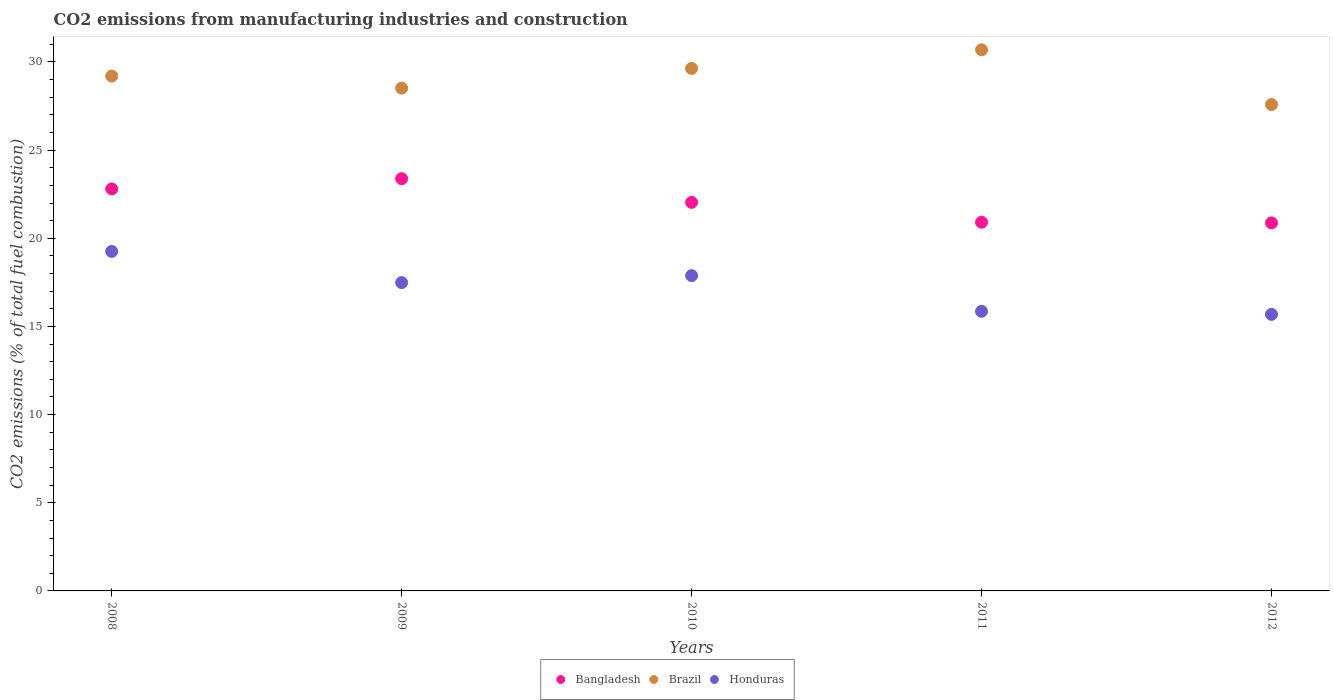Is the number of dotlines equal to the number of legend labels?
Your answer should be very brief. Yes. What is the amount of CO2 emitted in Bangladesh in 2008?
Your answer should be very brief. 22.8. Across all years, what is the maximum amount of CO2 emitted in Brazil?
Provide a succinct answer. 30.69. Across all years, what is the minimum amount of CO2 emitted in Bangladesh?
Offer a terse response. 20.87. In which year was the amount of CO2 emitted in Bangladesh minimum?
Ensure brevity in your answer.  2012. What is the total amount of CO2 emitted in Brazil in the graph?
Offer a terse response. 145.63. What is the difference between the amount of CO2 emitted in Honduras in 2008 and that in 2010?
Provide a short and direct response. 1.37. What is the difference between the amount of CO2 emitted in Brazil in 2010 and the amount of CO2 emitted in Honduras in 2009?
Keep it short and to the point. 12.15. What is the average amount of CO2 emitted in Bangladesh per year?
Keep it short and to the point. 22. In the year 2009, what is the difference between the amount of CO2 emitted in Bangladesh and amount of CO2 emitted in Brazil?
Make the answer very short. -5.14. What is the ratio of the amount of CO2 emitted in Bangladesh in 2011 to that in 2012?
Give a very brief answer. 1. Is the difference between the amount of CO2 emitted in Bangladesh in 2010 and 2012 greater than the difference between the amount of CO2 emitted in Brazil in 2010 and 2012?
Make the answer very short. No. What is the difference between the highest and the second highest amount of CO2 emitted in Brazil?
Ensure brevity in your answer.  1.06. What is the difference between the highest and the lowest amount of CO2 emitted in Bangladesh?
Your answer should be compact. 2.51. In how many years, is the amount of CO2 emitted in Brazil greater than the average amount of CO2 emitted in Brazil taken over all years?
Keep it short and to the point. 3. Is the sum of the amount of CO2 emitted in Bangladesh in 2008 and 2012 greater than the maximum amount of CO2 emitted in Honduras across all years?
Ensure brevity in your answer.  Yes. Is it the case that in every year, the sum of the amount of CO2 emitted in Honduras and amount of CO2 emitted in Brazil  is greater than the amount of CO2 emitted in Bangladesh?
Ensure brevity in your answer.  Yes. Is the amount of CO2 emitted in Bangladesh strictly less than the amount of CO2 emitted in Brazil over the years?
Give a very brief answer. Yes. Does the graph contain any zero values?
Your answer should be very brief. No. Does the graph contain grids?
Your answer should be compact. No. What is the title of the graph?
Ensure brevity in your answer.  CO2 emissions from manufacturing industries and construction. Does "Papua New Guinea" appear as one of the legend labels in the graph?
Ensure brevity in your answer.  No. What is the label or title of the X-axis?
Your answer should be very brief. Years. What is the label or title of the Y-axis?
Give a very brief answer. CO2 emissions (% of total fuel combustion). What is the CO2 emissions (% of total fuel combustion) in Bangladesh in 2008?
Offer a very short reply. 22.8. What is the CO2 emissions (% of total fuel combustion) in Brazil in 2008?
Offer a very short reply. 29.2. What is the CO2 emissions (% of total fuel combustion) of Honduras in 2008?
Make the answer very short. 19.26. What is the CO2 emissions (% of total fuel combustion) in Bangladesh in 2009?
Your answer should be compact. 23.38. What is the CO2 emissions (% of total fuel combustion) of Brazil in 2009?
Provide a succinct answer. 28.52. What is the CO2 emissions (% of total fuel combustion) of Honduras in 2009?
Your answer should be very brief. 17.49. What is the CO2 emissions (% of total fuel combustion) of Bangladesh in 2010?
Offer a terse response. 22.04. What is the CO2 emissions (% of total fuel combustion) in Brazil in 2010?
Provide a short and direct response. 29.63. What is the CO2 emissions (% of total fuel combustion) of Honduras in 2010?
Ensure brevity in your answer.  17.88. What is the CO2 emissions (% of total fuel combustion) in Bangladesh in 2011?
Your answer should be compact. 20.91. What is the CO2 emissions (% of total fuel combustion) of Brazil in 2011?
Give a very brief answer. 30.69. What is the CO2 emissions (% of total fuel combustion) of Honduras in 2011?
Offer a very short reply. 15.86. What is the CO2 emissions (% of total fuel combustion) in Bangladesh in 2012?
Your answer should be compact. 20.87. What is the CO2 emissions (% of total fuel combustion) in Brazil in 2012?
Keep it short and to the point. 27.58. What is the CO2 emissions (% of total fuel combustion) of Honduras in 2012?
Make the answer very short. 15.69. Across all years, what is the maximum CO2 emissions (% of total fuel combustion) of Bangladesh?
Your answer should be compact. 23.38. Across all years, what is the maximum CO2 emissions (% of total fuel combustion) in Brazil?
Make the answer very short. 30.69. Across all years, what is the maximum CO2 emissions (% of total fuel combustion) of Honduras?
Keep it short and to the point. 19.26. Across all years, what is the minimum CO2 emissions (% of total fuel combustion) in Bangladesh?
Offer a terse response. 20.87. Across all years, what is the minimum CO2 emissions (% of total fuel combustion) in Brazil?
Offer a very short reply. 27.58. Across all years, what is the minimum CO2 emissions (% of total fuel combustion) of Honduras?
Offer a terse response. 15.69. What is the total CO2 emissions (% of total fuel combustion) of Bangladesh in the graph?
Keep it short and to the point. 110.01. What is the total CO2 emissions (% of total fuel combustion) in Brazil in the graph?
Give a very brief answer. 145.63. What is the total CO2 emissions (% of total fuel combustion) in Honduras in the graph?
Your response must be concise. 86.17. What is the difference between the CO2 emissions (% of total fuel combustion) in Bangladesh in 2008 and that in 2009?
Your answer should be very brief. -0.58. What is the difference between the CO2 emissions (% of total fuel combustion) in Brazil in 2008 and that in 2009?
Offer a terse response. 0.68. What is the difference between the CO2 emissions (% of total fuel combustion) of Honduras in 2008 and that in 2009?
Your answer should be very brief. 1.77. What is the difference between the CO2 emissions (% of total fuel combustion) in Bangladesh in 2008 and that in 2010?
Your answer should be very brief. 0.76. What is the difference between the CO2 emissions (% of total fuel combustion) in Brazil in 2008 and that in 2010?
Offer a very short reply. -0.43. What is the difference between the CO2 emissions (% of total fuel combustion) in Honduras in 2008 and that in 2010?
Keep it short and to the point. 1.37. What is the difference between the CO2 emissions (% of total fuel combustion) in Bangladesh in 2008 and that in 2011?
Offer a terse response. 1.89. What is the difference between the CO2 emissions (% of total fuel combustion) of Brazil in 2008 and that in 2011?
Give a very brief answer. -1.49. What is the difference between the CO2 emissions (% of total fuel combustion) of Honduras in 2008 and that in 2011?
Keep it short and to the point. 3.4. What is the difference between the CO2 emissions (% of total fuel combustion) of Bangladesh in 2008 and that in 2012?
Your answer should be very brief. 1.93. What is the difference between the CO2 emissions (% of total fuel combustion) of Brazil in 2008 and that in 2012?
Offer a terse response. 1.62. What is the difference between the CO2 emissions (% of total fuel combustion) of Honduras in 2008 and that in 2012?
Give a very brief answer. 3.57. What is the difference between the CO2 emissions (% of total fuel combustion) of Bangladesh in 2009 and that in 2010?
Offer a very short reply. 1.34. What is the difference between the CO2 emissions (% of total fuel combustion) in Brazil in 2009 and that in 2010?
Keep it short and to the point. -1.11. What is the difference between the CO2 emissions (% of total fuel combustion) in Honduras in 2009 and that in 2010?
Make the answer very short. -0.4. What is the difference between the CO2 emissions (% of total fuel combustion) of Bangladesh in 2009 and that in 2011?
Offer a terse response. 2.47. What is the difference between the CO2 emissions (% of total fuel combustion) of Brazil in 2009 and that in 2011?
Make the answer very short. -2.17. What is the difference between the CO2 emissions (% of total fuel combustion) in Honduras in 2009 and that in 2011?
Provide a succinct answer. 1.63. What is the difference between the CO2 emissions (% of total fuel combustion) in Bangladesh in 2009 and that in 2012?
Provide a short and direct response. 2.51. What is the difference between the CO2 emissions (% of total fuel combustion) of Honduras in 2009 and that in 2012?
Keep it short and to the point. 1.8. What is the difference between the CO2 emissions (% of total fuel combustion) of Bangladesh in 2010 and that in 2011?
Make the answer very short. 1.13. What is the difference between the CO2 emissions (% of total fuel combustion) of Brazil in 2010 and that in 2011?
Make the answer very short. -1.06. What is the difference between the CO2 emissions (% of total fuel combustion) in Honduras in 2010 and that in 2011?
Make the answer very short. 2.02. What is the difference between the CO2 emissions (% of total fuel combustion) in Bangladesh in 2010 and that in 2012?
Make the answer very short. 1.16. What is the difference between the CO2 emissions (% of total fuel combustion) in Brazil in 2010 and that in 2012?
Ensure brevity in your answer.  2.05. What is the difference between the CO2 emissions (% of total fuel combustion) in Honduras in 2010 and that in 2012?
Provide a succinct answer. 2.2. What is the difference between the CO2 emissions (% of total fuel combustion) in Bangladesh in 2011 and that in 2012?
Your answer should be compact. 0.04. What is the difference between the CO2 emissions (% of total fuel combustion) in Brazil in 2011 and that in 2012?
Offer a very short reply. 3.11. What is the difference between the CO2 emissions (% of total fuel combustion) of Honduras in 2011 and that in 2012?
Make the answer very short. 0.17. What is the difference between the CO2 emissions (% of total fuel combustion) of Bangladesh in 2008 and the CO2 emissions (% of total fuel combustion) of Brazil in 2009?
Make the answer very short. -5.72. What is the difference between the CO2 emissions (% of total fuel combustion) in Bangladesh in 2008 and the CO2 emissions (% of total fuel combustion) in Honduras in 2009?
Your response must be concise. 5.32. What is the difference between the CO2 emissions (% of total fuel combustion) of Brazil in 2008 and the CO2 emissions (% of total fuel combustion) of Honduras in 2009?
Keep it short and to the point. 11.72. What is the difference between the CO2 emissions (% of total fuel combustion) in Bangladesh in 2008 and the CO2 emissions (% of total fuel combustion) in Brazil in 2010?
Offer a very short reply. -6.83. What is the difference between the CO2 emissions (% of total fuel combustion) in Bangladesh in 2008 and the CO2 emissions (% of total fuel combustion) in Honduras in 2010?
Give a very brief answer. 4.92. What is the difference between the CO2 emissions (% of total fuel combustion) in Brazil in 2008 and the CO2 emissions (% of total fuel combustion) in Honduras in 2010?
Offer a terse response. 11.32. What is the difference between the CO2 emissions (% of total fuel combustion) in Bangladesh in 2008 and the CO2 emissions (% of total fuel combustion) in Brazil in 2011?
Your answer should be very brief. -7.89. What is the difference between the CO2 emissions (% of total fuel combustion) of Bangladesh in 2008 and the CO2 emissions (% of total fuel combustion) of Honduras in 2011?
Make the answer very short. 6.94. What is the difference between the CO2 emissions (% of total fuel combustion) of Brazil in 2008 and the CO2 emissions (% of total fuel combustion) of Honduras in 2011?
Your answer should be very brief. 13.34. What is the difference between the CO2 emissions (% of total fuel combustion) of Bangladesh in 2008 and the CO2 emissions (% of total fuel combustion) of Brazil in 2012?
Offer a terse response. -4.78. What is the difference between the CO2 emissions (% of total fuel combustion) of Bangladesh in 2008 and the CO2 emissions (% of total fuel combustion) of Honduras in 2012?
Provide a short and direct response. 7.12. What is the difference between the CO2 emissions (% of total fuel combustion) in Brazil in 2008 and the CO2 emissions (% of total fuel combustion) in Honduras in 2012?
Offer a very short reply. 13.52. What is the difference between the CO2 emissions (% of total fuel combustion) of Bangladesh in 2009 and the CO2 emissions (% of total fuel combustion) of Brazil in 2010?
Provide a succinct answer. -6.25. What is the difference between the CO2 emissions (% of total fuel combustion) in Bangladesh in 2009 and the CO2 emissions (% of total fuel combustion) in Honduras in 2010?
Your answer should be compact. 5.5. What is the difference between the CO2 emissions (% of total fuel combustion) of Brazil in 2009 and the CO2 emissions (% of total fuel combustion) of Honduras in 2010?
Your response must be concise. 10.64. What is the difference between the CO2 emissions (% of total fuel combustion) of Bangladesh in 2009 and the CO2 emissions (% of total fuel combustion) of Brazil in 2011?
Provide a short and direct response. -7.31. What is the difference between the CO2 emissions (% of total fuel combustion) in Bangladesh in 2009 and the CO2 emissions (% of total fuel combustion) in Honduras in 2011?
Offer a very short reply. 7.52. What is the difference between the CO2 emissions (% of total fuel combustion) in Brazil in 2009 and the CO2 emissions (% of total fuel combustion) in Honduras in 2011?
Your answer should be very brief. 12.66. What is the difference between the CO2 emissions (% of total fuel combustion) in Bangladesh in 2009 and the CO2 emissions (% of total fuel combustion) in Brazil in 2012?
Keep it short and to the point. -4.2. What is the difference between the CO2 emissions (% of total fuel combustion) in Bangladesh in 2009 and the CO2 emissions (% of total fuel combustion) in Honduras in 2012?
Your response must be concise. 7.7. What is the difference between the CO2 emissions (% of total fuel combustion) of Brazil in 2009 and the CO2 emissions (% of total fuel combustion) of Honduras in 2012?
Offer a terse response. 12.83. What is the difference between the CO2 emissions (% of total fuel combustion) of Bangladesh in 2010 and the CO2 emissions (% of total fuel combustion) of Brazil in 2011?
Ensure brevity in your answer.  -8.65. What is the difference between the CO2 emissions (% of total fuel combustion) in Bangladesh in 2010 and the CO2 emissions (% of total fuel combustion) in Honduras in 2011?
Your answer should be compact. 6.18. What is the difference between the CO2 emissions (% of total fuel combustion) of Brazil in 2010 and the CO2 emissions (% of total fuel combustion) of Honduras in 2011?
Offer a very short reply. 13.77. What is the difference between the CO2 emissions (% of total fuel combustion) in Bangladesh in 2010 and the CO2 emissions (% of total fuel combustion) in Brazil in 2012?
Offer a terse response. -5.55. What is the difference between the CO2 emissions (% of total fuel combustion) in Bangladesh in 2010 and the CO2 emissions (% of total fuel combustion) in Honduras in 2012?
Make the answer very short. 6.35. What is the difference between the CO2 emissions (% of total fuel combustion) in Brazil in 2010 and the CO2 emissions (% of total fuel combustion) in Honduras in 2012?
Your response must be concise. 13.95. What is the difference between the CO2 emissions (% of total fuel combustion) in Bangladesh in 2011 and the CO2 emissions (% of total fuel combustion) in Brazil in 2012?
Provide a short and direct response. -6.67. What is the difference between the CO2 emissions (% of total fuel combustion) in Bangladesh in 2011 and the CO2 emissions (% of total fuel combustion) in Honduras in 2012?
Give a very brief answer. 5.23. What is the difference between the CO2 emissions (% of total fuel combustion) of Brazil in 2011 and the CO2 emissions (% of total fuel combustion) of Honduras in 2012?
Your answer should be compact. 15. What is the average CO2 emissions (% of total fuel combustion) in Bangladesh per year?
Your answer should be compact. 22. What is the average CO2 emissions (% of total fuel combustion) of Brazil per year?
Provide a short and direct response. 29.13. What is the average CO2 emissions (% of total fuel combustion) of Honduras per year?
Your answer should be very brief. 17.23. In the year 2008, what is the difference between the CO2 emissions (% of total fuel combustion) in Bangladesh and CO2 emissions (% of total fuel combustion) in Brazil?
Provide a succinct answer. -6.4. In the year 2008, what is the difference between the CO2 emissions (% of total fuel combustion) in Bangladesh and CO2 emissions (% of total fuel combustion) in Honduras?
Offer a terse response. 3.55. In the year 2008, what is the difference between the CO2 emissions (% of total fuel combustion) in Brazil and CO2 emissions (% of total fuel combustion) in Honduras?
Your answer should be very brief. 9.95. In the year 2009, what is the difference between the CO2 emissions (% of total fuel combustion) in Bangladesh and CO2 emissions (% of total fuel combustion) in Brazil?
Offer a very short reply. -5.14. In the year 2009, what is the difference between the CO2 emissions (% of total fuel combustion) in Bangladesh and CO2 emissions (% of total fuel combustion) in Honduras?
Provide a short and direct response. 5.9. In the year 2009, what is the difference between the CO2 emissions (% of total fuel combustion) in Brazil and CO2 emissions (% of total fuel combustion) in Honduras?
Provide a short and direct response. 11.03. In the year 2010, what is the difference between the CO2 emissions (% of total fuel combustion) in Bangladesh and CO2 emissions (% of total fuel combustion) in Brazil?
Provide a succinct answer. -7.59. In the year 2010, what is the difference between the CO2 emissions (% of total fuel combustion) of Bangladesh and CO2 emissions (% of total fuel combustion) of Honduras?
Provide a succinct answer. 4.16. In the year 2010, what is the difference between the CO2 emissions (% of total fuel combustion) in Brazil and CO2 emissions (% of total fuel combustion) in Honduras?
Offer a terse response. 11.75. In the year 2011, what is the difference between the CO2 emissions (% of total fuel combustion) of Bangladesh and CO2 emissions (% of total fuel combustion) of Brazil?
Provide a short and direct response. -9.78. In the year 2011, what is the difference between the CO2 emissions (% of total fuel combustion) in Bangladesh and CO2 emissions (% of total fuel combustion) in Honduras?
Provide a succinct answer. 5.05. In the year 2011, what is the difference between the CO2 emissions (% of total fuel combustion) of Brazil and CO2 emissions (% of total fuel combustion) of Honduras?
Keep it short and to the point. 14.83. In the year 2012, what is the difference between the CO2 emissions (% of total fuel combustion) in Bangladesh and CO2 emissions (% of total fuel combustion) in Brazil?
Give a very brief answer. -6.71. In the year 2012, what is the difference between the CO2 emissions (% of total fuel combustion) in Bangladesh and CO2 emissions (% of total fuel combustion) in Honduras?
Make the answer very short. 5.19. In the year 2012, what is the difference between the CO2 emissions (% of total fuel combustion) of Brazil and CO2 emissions (% of total fuel combustion) of Honduras?
Offer a terse response. 11.9. What is the ratio of the CO2 emissions (% of total fuel combustion) of Bangladesh in 2008 to that in 2009?
Ensure brevity in your answer.  0.98. What is the ratio of the CO2 emissions (% of total fuel combustion) in Brazil in 2008 to that in 2009?
Make the answer very short. 1.02. What is the ratio of the CO2 emissions (% of total fuel combustion) of Honduras in 2008 to that in 2009?
Offer a very short reply. 1.1. What is the ratio of the CO2 emissions (% of total fuel combustion) in Bangladesh in 2008 to that in 2010?
Make the answer very short. 1.03. What is the ratio of the CO2 emissions (% of total fuel combustion) of Brazil in 2008 to that in 2010?
Provide a short and direct response. 0.99. What is the ratio of the CO2 emissions (% of total fuel combustion) in Honduras in 2008 to that in 2010?
Give a very brief answer. 1.08. What is the ratio of the CO2 emissions (% of total fuel combustion) of Bangladesh in 2008 to that in 2011?
Keep it short and to the point. 1.09. What is the ratio of the CO2 emissions (% of total fuel combustion) of Brazil in 2008 to that in 2011?
Offer a terse response. 0.95. What is the ratio of the CO2 emissions (% of total fuel combustion) in Honduras in 2008 to that in 2011?
Ensure brevity in your answer.  1.21. What is the ratio of the CO2 emissions (% of total fuel combustion) of Bangladesh in 2008 to that in 2012?
Ensure brevity in your answer.  1.09. What is the ratio of the CO2 emissions (% of total fuel combustion) of Brazil in 2008 to that in 2012?
Offer a terse response. 1.06. What is the ratio of the CO2 emissions (% of total fuel combustion) of Honduras in 2008 to that in 2012?
Give a very brief answer. 1.23. What is the ratio of the CO2 emissions (% of total fuel combustion) in Bangladesh in 2009 to that in 2010?
Provide a short and direct response. 1.06. What is the ratio of the CO2 emissions (% of total fuel combustion) of Brazil in 2009 to that in 2010?
Give a very brief answer. 0.96. What is the ratio of the CO2 emissions (% of total fuel combustion) of Honduras in 2009 to that in 2010?
Ensure brevity in your answer.  0.98. What is the ratio of the CO2 emissions (% of total fuel combustion) of Bangladesh in 2009 to that in 2011?
Offer a terse response. 1.12. What is the ratio of the CO2 emissions (% of total fuel combustion) in Brazil in 2009 to that in 2011?
Your answer should be very brief. 0.93. What is the ratio of the CO2 emissions (% of total fuel combustion) of Honduras in 2009 to that in 2011?
Provide a succinct answer. 1.1. What is the ratio of the CO2 emissions (% of total fuel combustion) in Bangladesh in 2009 to that in 2012?
Give a very brief answer. 1.12. What is the ratio of the CO2 emissions (% of total fuel combustion) of Brazil in 2009 to that in 2012?
Offer a very short reply. 1.03. What is the ratio of the CO2 emissions (% of total fuel combustion) in Honduras in 2009 to that in 2012?
Your response must be concise. 1.11. What is the ratio of the CO2 emissions (% of total fuel combustion) in Bangladesh in 2010 to that in 2011?
Give a very brief answer. 1.05. What is the ratio of the CO2 emissions (% of total fuel combustion) in Brazil in 2010 to that in 2011?
Ensure brevity in your answer.  0.97. What is the ratio of the CO2 emissions (% of total fuel combustion) of Honduras in 2010 to that in 2011?
Offer a very short reply. 1.13. What is the ratio of the CO2 emissions (% of total fuel combustion) of Bangladesh in 2010 to that in 2012?
Make the answer very short. 1.06. What is the ratio of the CO2 emissions (% of total fuel combustion) of Brazil in 2010 to that in 2012?
Offer a very short reply. 1.07. What is the ratio of the CO2 emissions (% of total fuel combustion) in Honduras in 2010 to that in 2012?
Your answer should be compact. 1.14. What is the ratio of the CO2 emissions (% of total fuel combustion) in Brazil in 2011 to that in 2012?
Provide a succinct answer. 1.11. What is the difference between the highest and the second highest CO2 emissions (% of total fuel combustion) of Bangladesh?
Your response must be concise. 0.58. What is the difference between the highest and the second highest CO2 emissions (% of total fuel combustion) of Brazil?
Offer a very short reply. 1.06. What is the difference between the highest and the second highest CO2 emissions (% of total fuel combustion) in Honduras?
Offer a very short reply. 1.37. What is the difference between the highest and the lowest CO2 emissions (% of total fuel combustion) in Bangladesh?
Your answer should be very brief. 2.51. What is the difference between the highest and the lowest CO2 emissions (% of total fuel combustion) in Brazil?
Your response must be concise. 3.11. What is the difference between the highest and the lowest CO2 emissions (% of total fuel combustion) in Honduras?
Offer a very short reply. 3.57. 